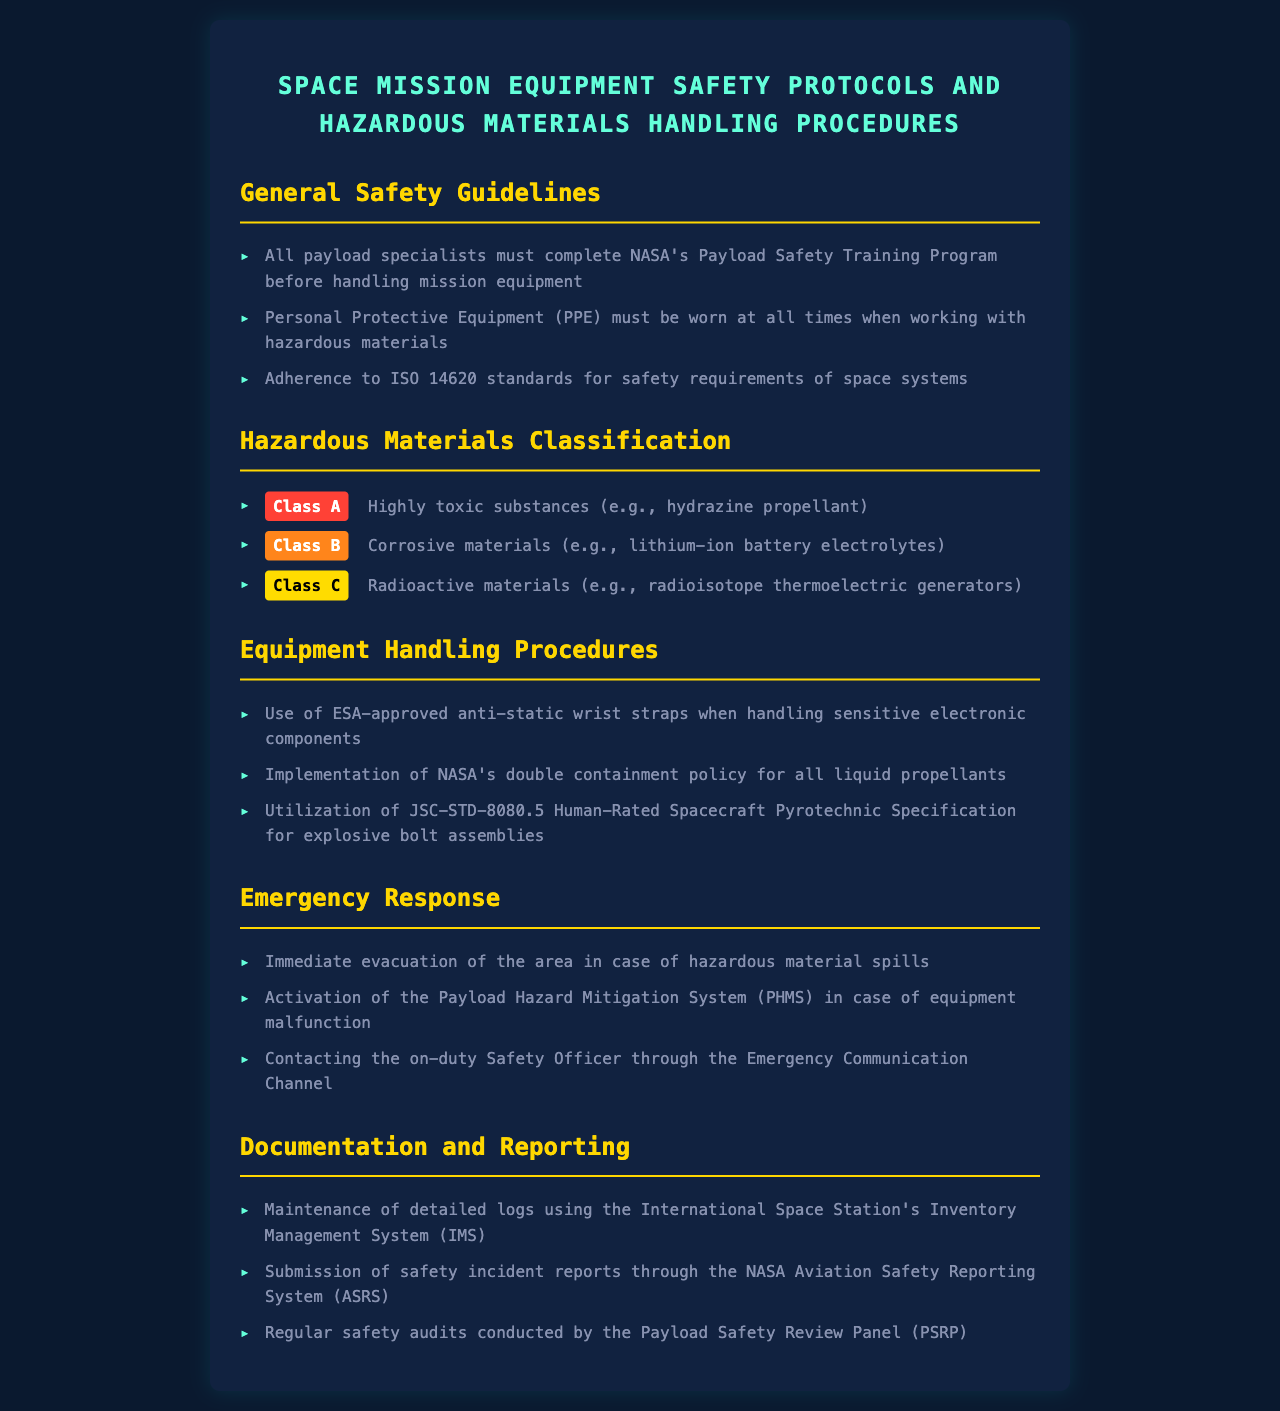What training program must payload specialists complete? The document states that all payload specialists must complete NASA's Payload Safety Training Program before handling mission equipment.
Answer: NASA's Payload Safety Training Program What do Personal Protective Equipment (PPE) need to be worn for? The document specifies that PPE must be worn at all times when working with hazardous materials.
Answer: Hazardous materials What is a Class A hazardous material example? According to the document, an example of a Class A hazardous material is hydrazine propellant.
Answer: Hydrazine propellant What procedure must be followed for liquid propellants? The document mentions that the implementation of NASA's double containment policy is required for all liquid propellants.
Answer: NASA's double containment policy What should be done in the case of hazardous material spills? The document indicates that immediate evacuation of the area should occur in the case of hazardous material spills.
Answer: Immediate evacuation What communication method should be used to contact the Safety Officer? The document advises contacting the on-duty Safety Officer through the Emergency Communication Channel.
Answer: Emergency Communication Channel What system is used for maintenance logs? The document states that detailed logs must be maintained using the International Space Station's Inventory Management System (IMS).
Answer: International Space Station's Inventory Management System How are safety incident reports submitted? The document specifies that safety incident reports should be submitted through the NASA Aviation Safety Reporting System (ASRS).
Answer: NASA Aviation Safety Reporting System What committee conducts regular safety audits? According to the document, regular safety audits are conducted by the Payload Safety Review Panel (PSRP).
Answer: Payload Safety Review Panel 